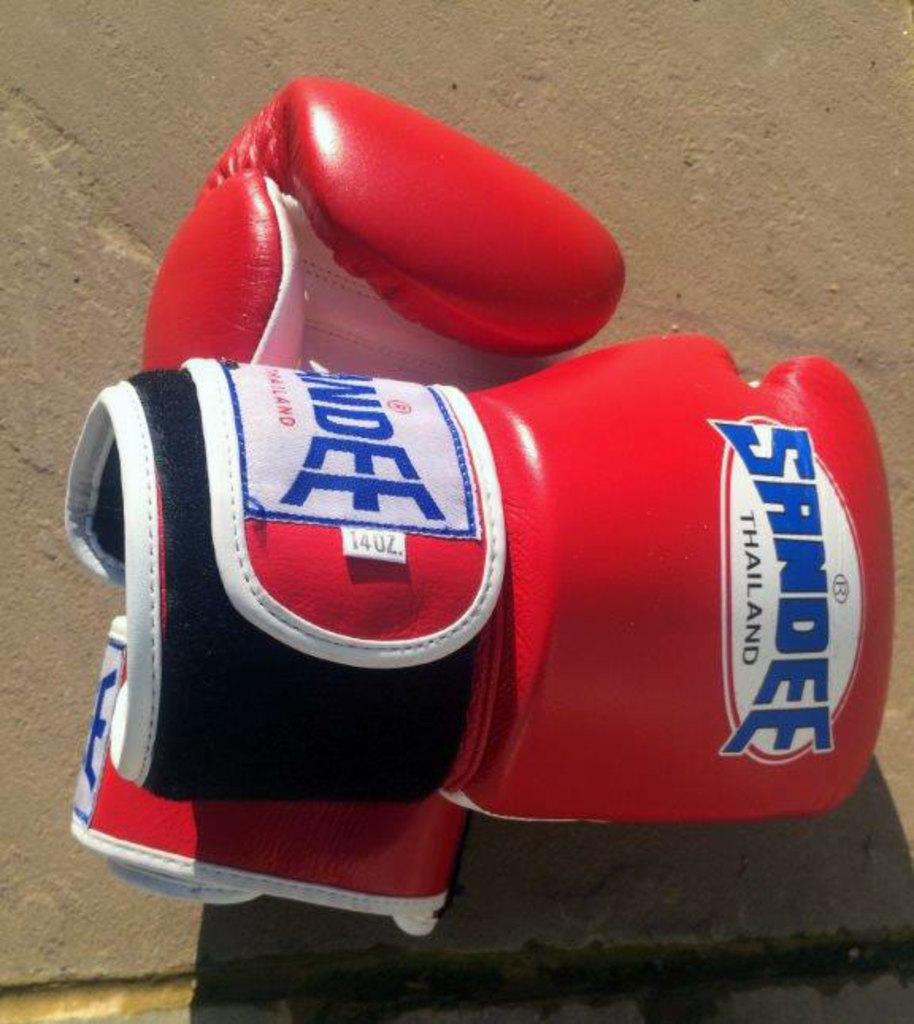What color are the gloves?
Offer a terse response. Answering does not require reading text in the image. What name brand are the boxing gloves?
Ensure brevity in your answer.  Sandee. 